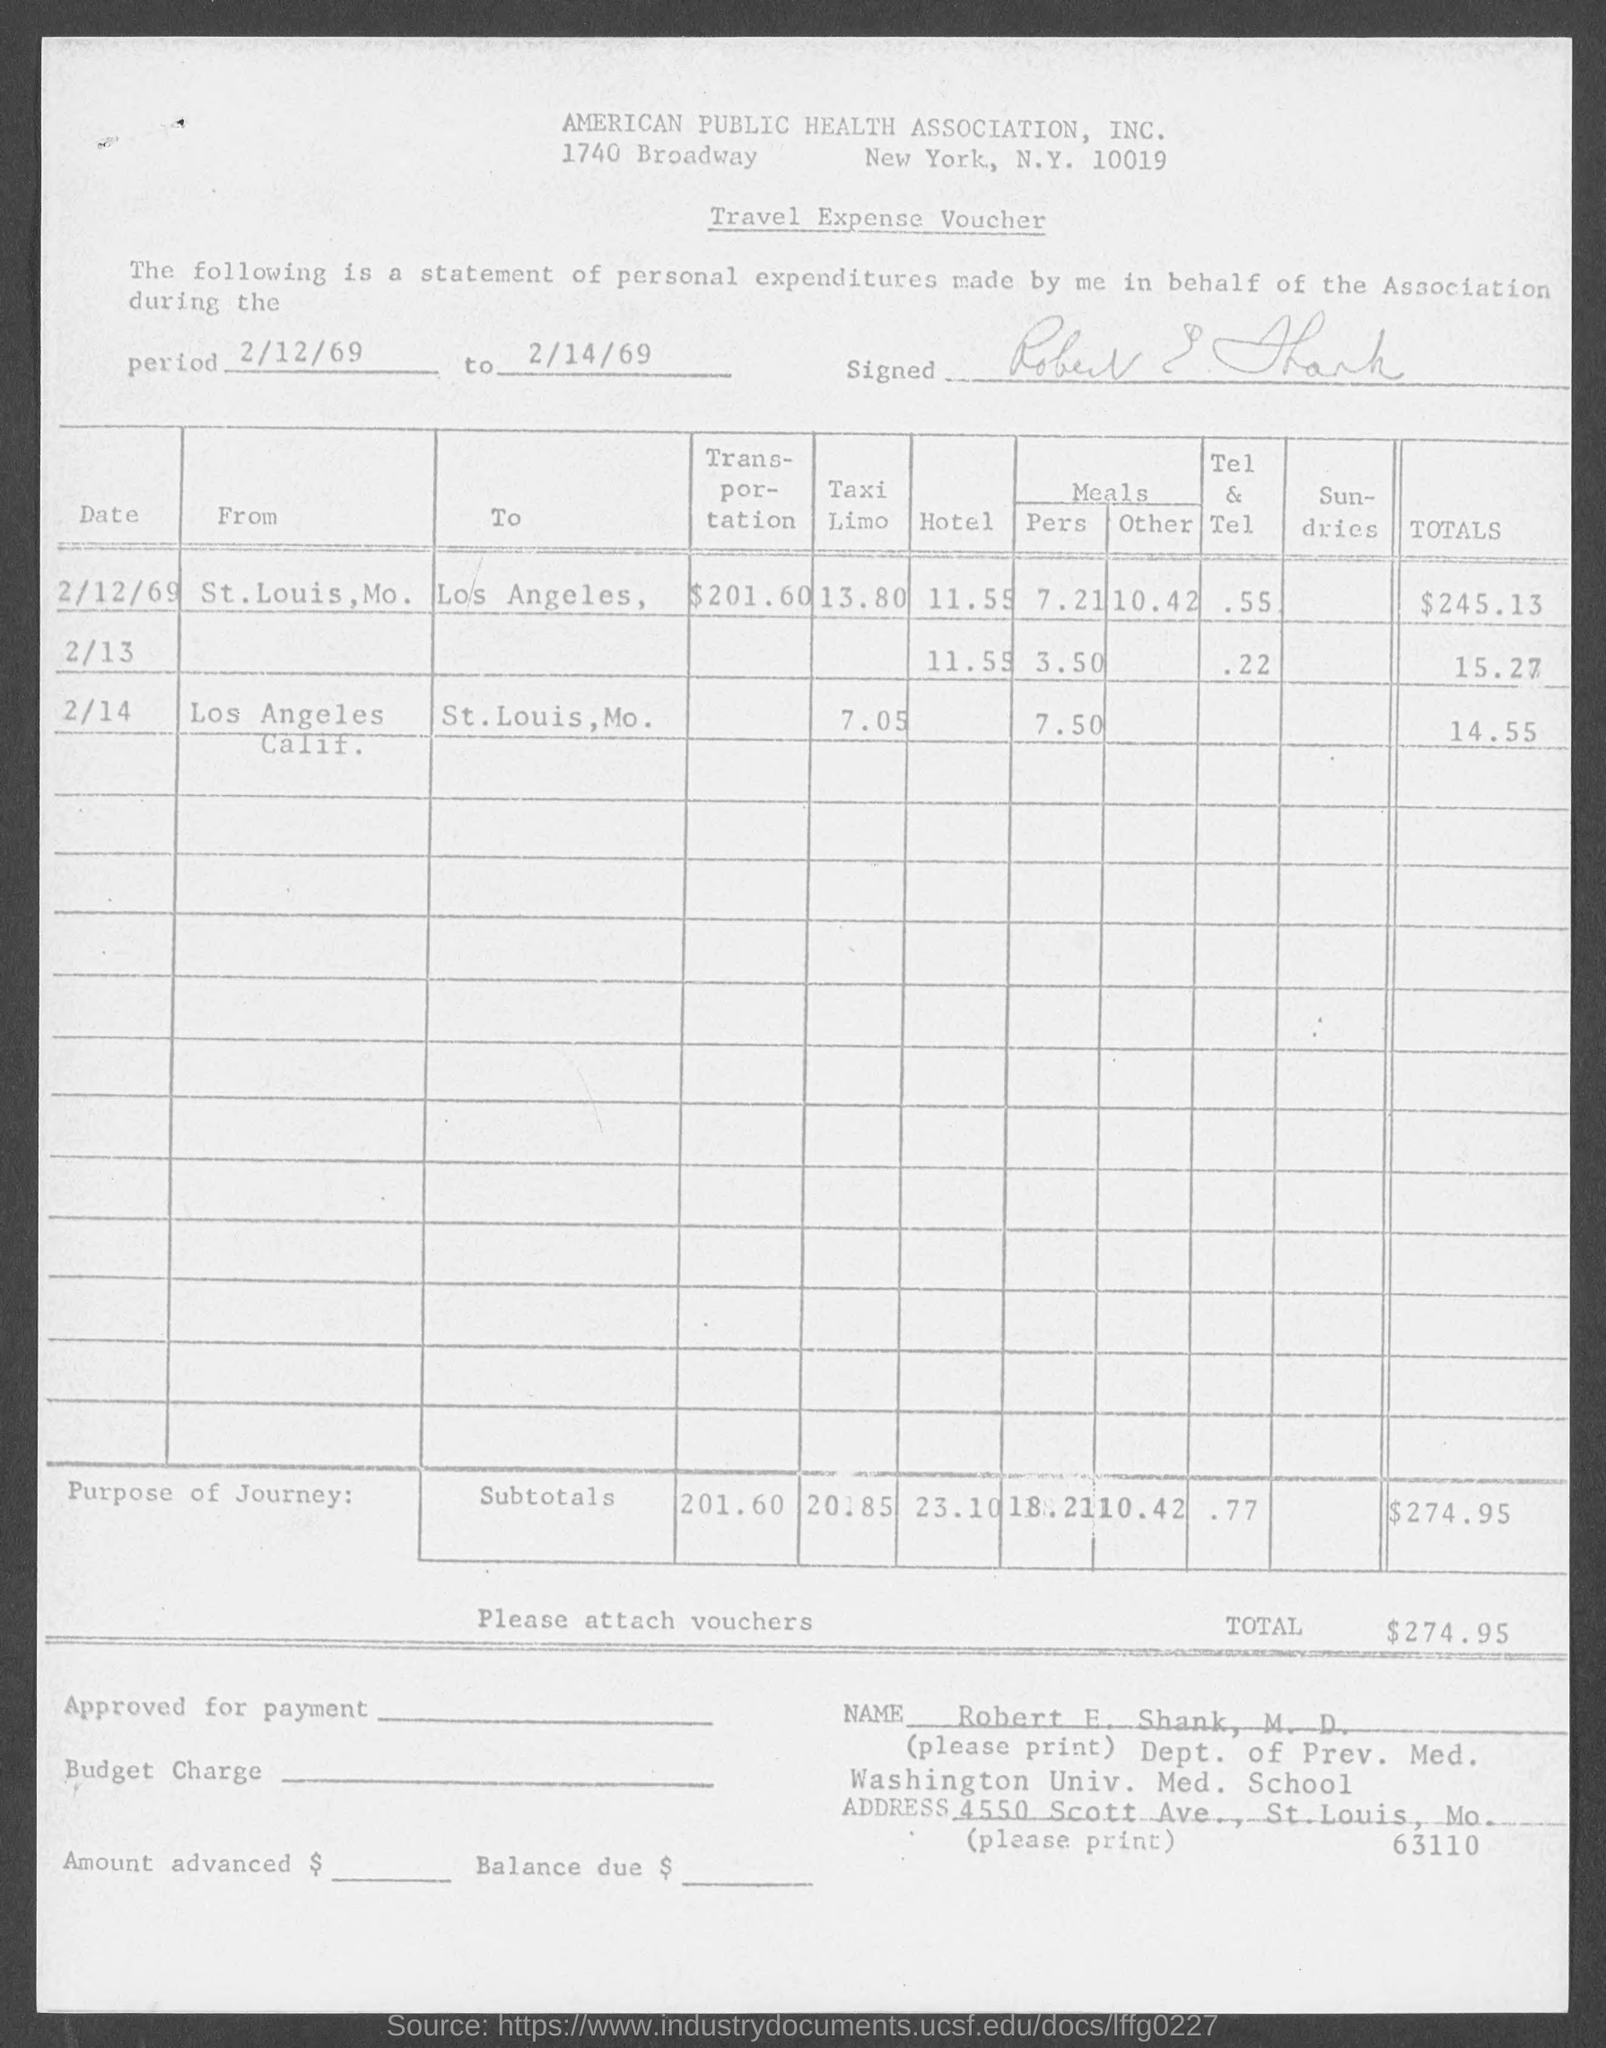Point out several critical features in this image. The period of travel expense voucher is from February 12th, 1969 to February 14th, 1969. The transportation expenses in St. Louis, Missouri were $201.60. The total amount on February 13th is 15.27. On February 12, 1969, the total amount was $245.13. The total on February 14th is [14.55]. 